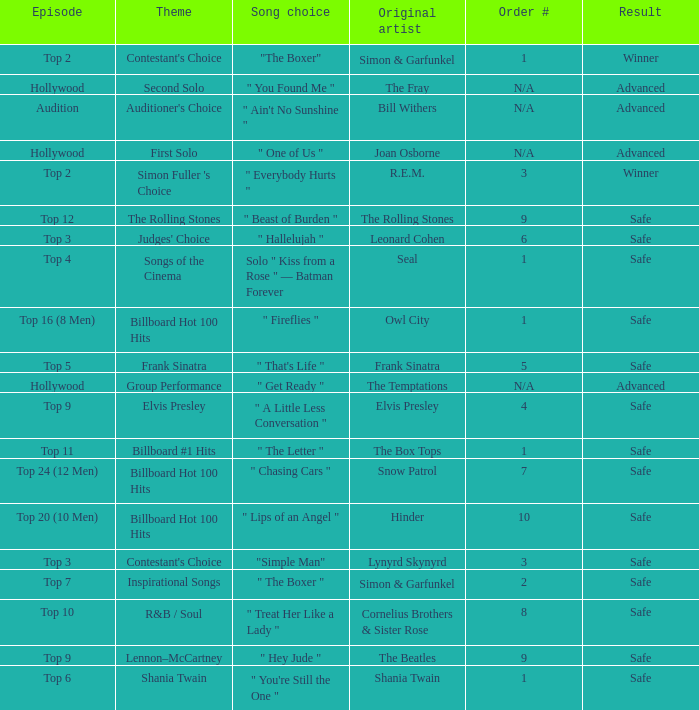Who is the original artist of the song choice " The Letter "? The Box Tops. 